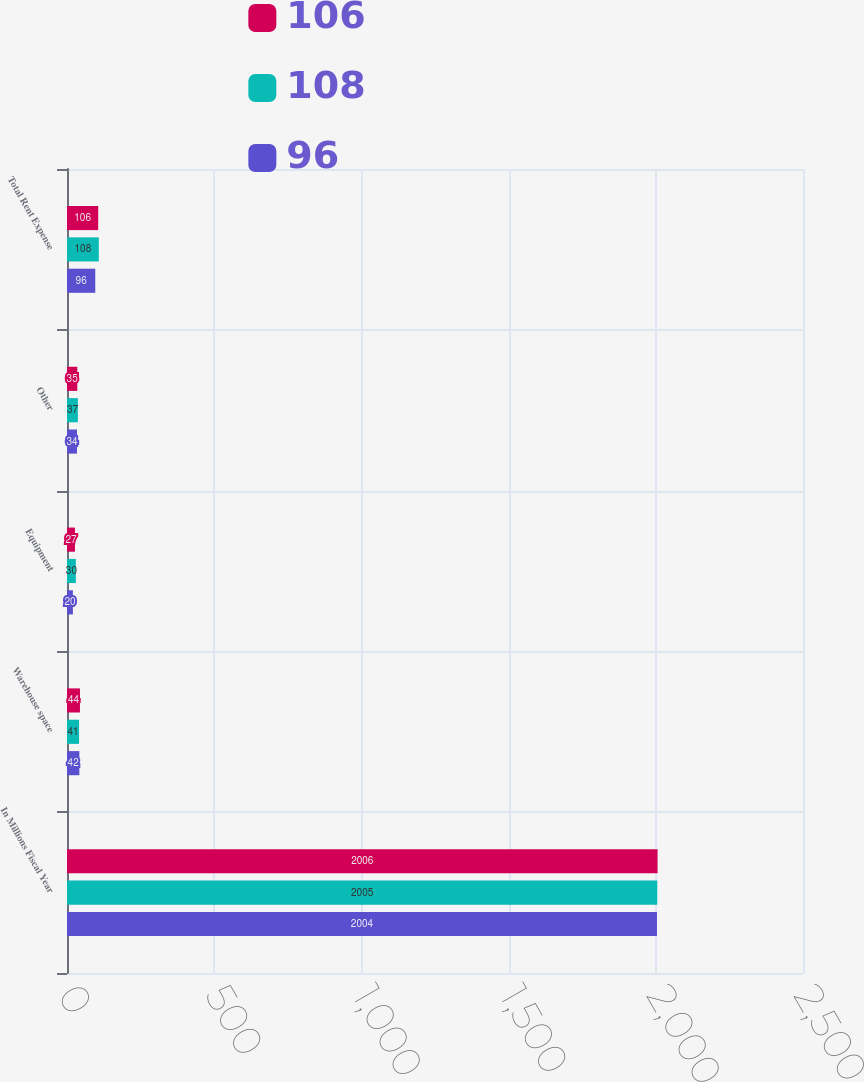Convert chart. <chart><loc_0><loc_0><loc_500><loc_500><stacked_bar_chart><ecel><fcel>In Millions Fiscal Year<fcel>Warehouse space<fcel>Equipment<fcel>Other<fcel>Total Rent Expense<nl><fcel>106<fcel>2006<fcel>44<fcel>27<fcel>35<fcel>106<nl><fcel>108<fcel>2005<fcel>41<fcel>30<fcel>37<fcel>108<nl><fcel>96<fcel>2004<fcel>42<fcel>20<fcel>34<fcel>96<nl></chart> 